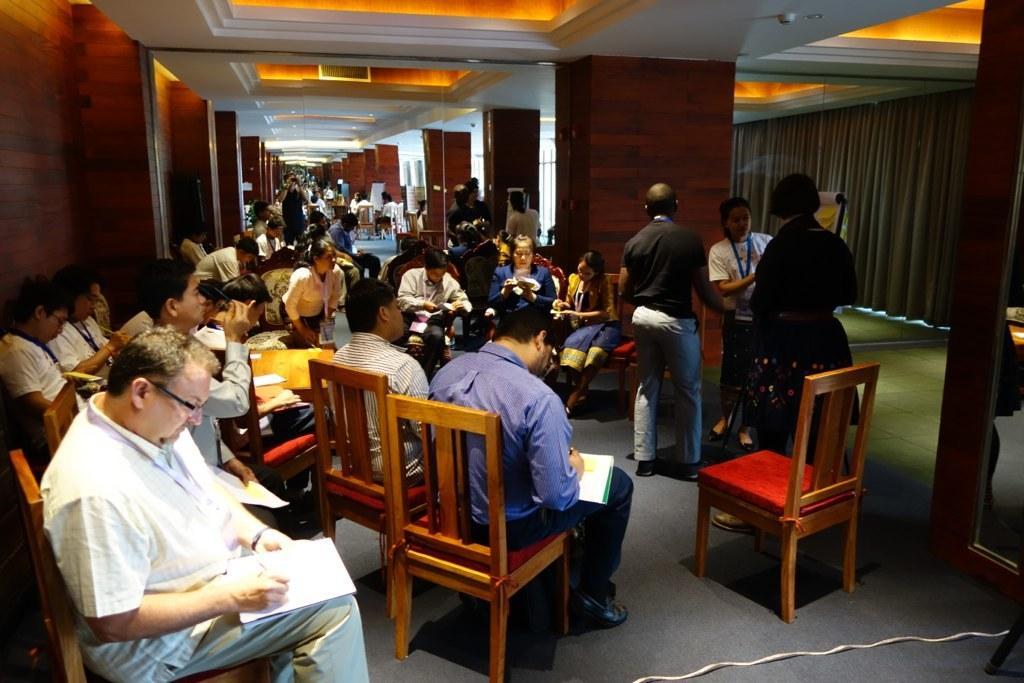Could you give a brief overview of what you see in this image? In this image there are group of persons who are sitting on the chairs and doing some work. 